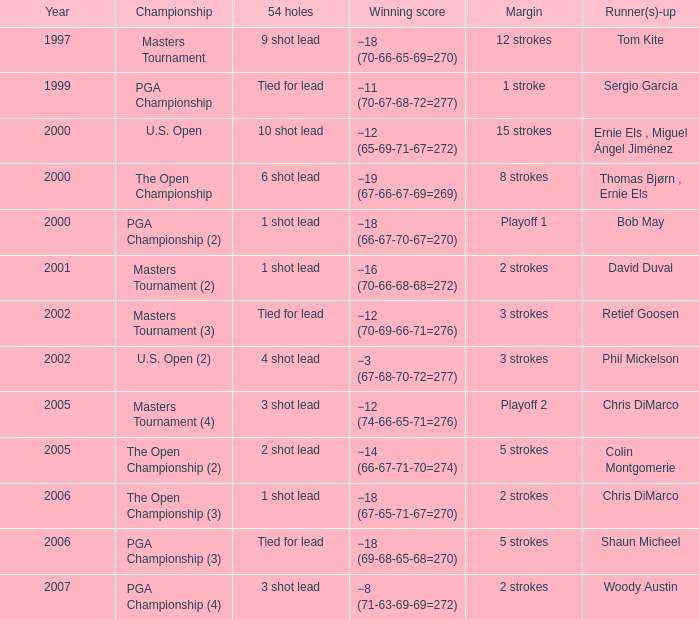During the lowest year, what is the winning score of -8 (71-63-69-69=272)? 2007.0. 